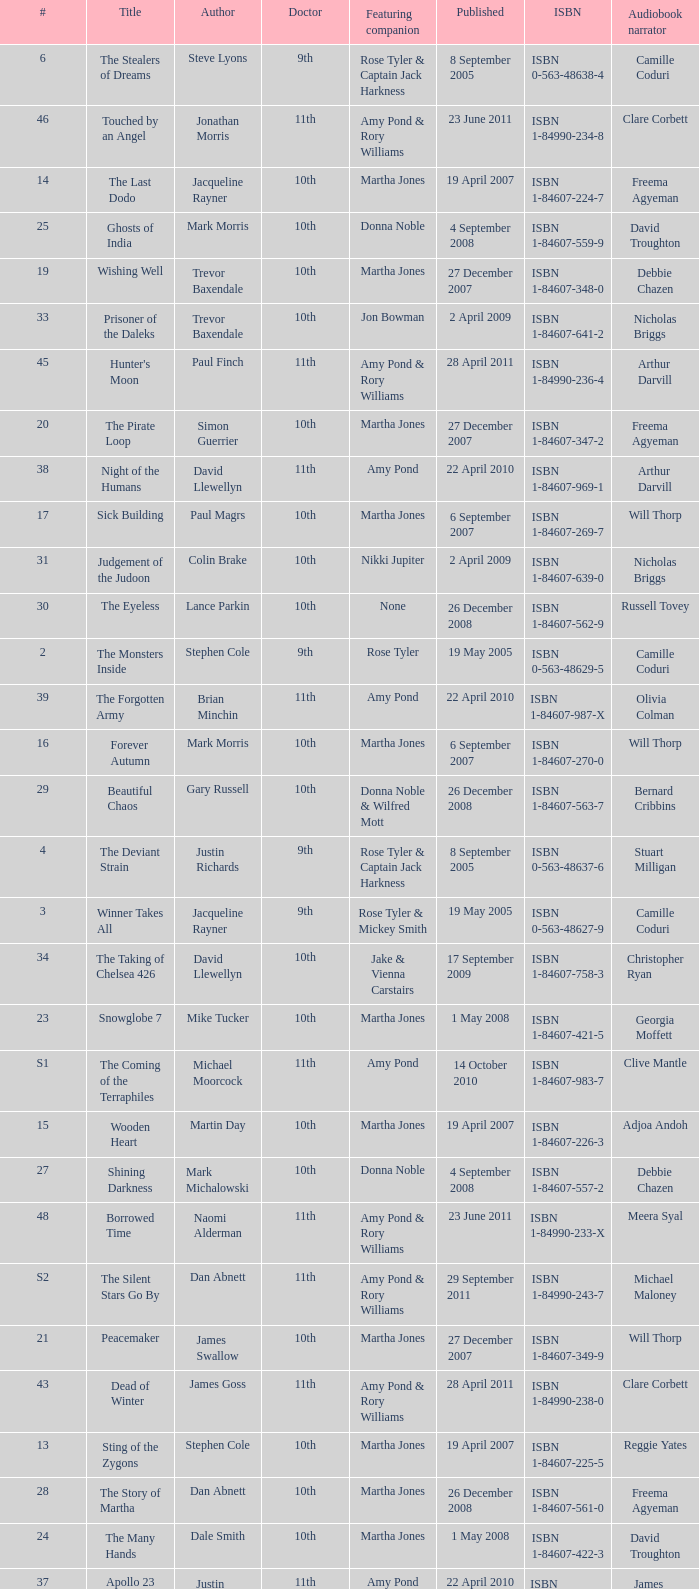What is the publication date of the book that is narrated by Michael Maloney? 29 September 2011. 